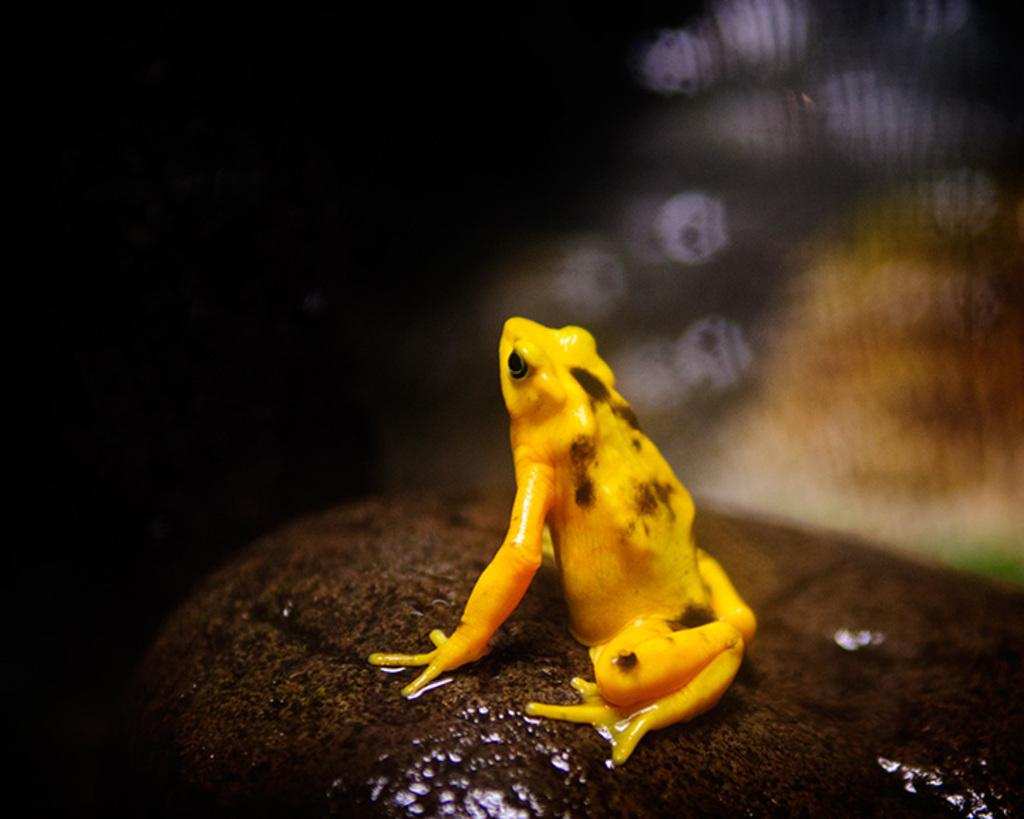What animal is present in the image? There is a frog in the image. Where is the frog located? The frog is on a rock. Can you describe the background of the image? The background of the image is blurred. What type of calendar is hanging on the wall in the image? There is no wall or calendar present in the image; it features a frog on a rock with a blurred background. 